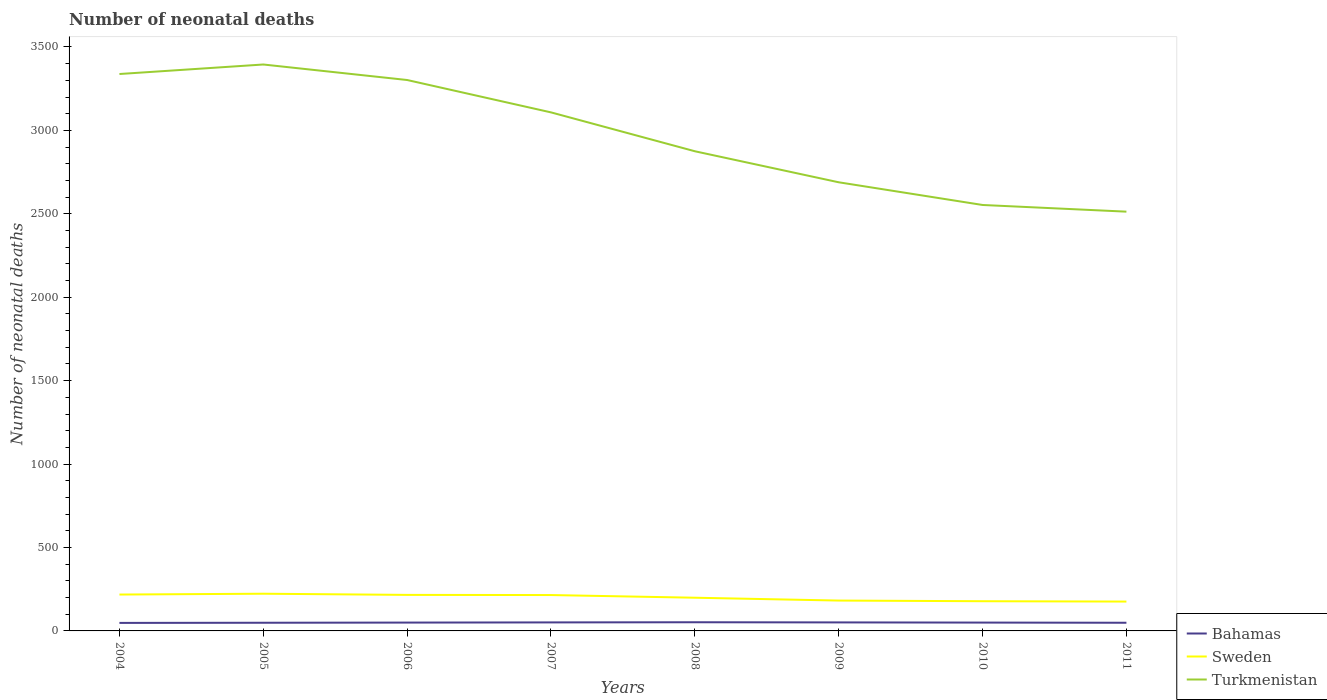Does the line corresponding to Bahamas intersect with the line corresponding to Turkmenistan?
Your answer should be very brief. No. Across all years, what is the maximum number of neonatal deaths in in Turkmenistan?
Offer a terse response. 2513. What is the total number of neonatal deaths in in Turkmenistan in the graph?
Your answer should be very brief. 40. What is the difference between the highest and the second highest number of neonatal deaths in in Turkmenistan?
Offer a very short reply. 882. What is the difference between the highest and the lowest number of neonatal deaths in in Sweden?
Your answer should be compact. 4. How many lines are there?
Offer a very short reply. 3. What is the difference between two consecutive major ticks on the Y-axis?
Ensure brevity in your answer.  500. Are the values on the major ticks of Y-axis written in scientific E-notation?
Offer a very short reply. No. Does the graph contain any zero values?
Provide a short and direct response. No. Does the graph contain grids?
Your answer should be compact. No. Where does the legend appear in the graph?
Keep it short and to the point. Bottom right. How many legend labels are there?
Ensure brevity in your answer.  3. What is the title of the graph?
Ensure brevity in your answer.  Number of neonatal deaths. What is the label or title of the X-axis?
Offer a very short reply. Years. What is the label or title of the Y-axis?
Ensure brevity in your answer.  Number of neonatal deaths. What is the Number of neonatal deaths in Bahamas in 2004?
Keep it short and to the point. 48. What is the Number of neonatal deaths in Sweden in 2004?
Your answer should be very brief. 218. What is the Number of neonatal deaths of Turkmenistan in 2004?
Provide a short and direct response. 3338. What is the Number of neonatal deaths of Sweden in 2005?
Provide a succinct answer. 223. What is the Number of neonatal deaths of Turkmenistan in 2005?
Your answer should be very brief. 3395. What is the Number of neonatal deaths in Bahamas in 2006?
Your answer should be compact. 50. What is the Number of neonatal deaths of Sweden in 2006?
Make the answer very short. 216. What is the Number of neonatal deaths of Turkmenistan in 2006?
Keep it short and to the point. 3302. What is the Number of neonatal deaths of Bahamas in 2007?
Your response must be concise. 51. What is the Number of neonatal deaths in Sweden in 2007?
Your answer should be compact. 215. What is the Number of neonatal deaths of Turkmenistan in 2007?
Give a very brief answer. 3108. What is the Number of neonatal deaths in Sweden in 2008?
Make the answer very short. 199. What is the Number of neonatal deaths of Turkmenistan in 2008?
Offer a very short reply. 2875. What is the Number of neonatal deaths of Sweden in 2009?
Offer a very short reply. 182. What is the Number of neonatal deaths in Turkmenistan in 2009?
Provide a succinct answer. 2689. What is the Number of neonatal deaths in Bahamas in 2010?
Ensure brevity in your answer.  50. What is the Number of neonatal deaths of Sweden in 2010?
Your answer should be very brief. 178. What is the Number of neonatal deaths of Turkmenistan in 2010?
Offer a very short reply. 2553. What is the Number of neonatal deaths in Sweden in 2011?
Give a very brief answer. 176. What is the Number of neonatal deaths of Turkmenistan in 2011?
Your response must be concise. 2513. Across all years, what is the maximum Number of neonatal deaths of Sweden?
Your answer should be compact. 223. Across all years, what is the maximum Number of neonatal deaths in Turkmenistan?
Offer a terse response. 3395. Across all years, what is the minimum Number of neonatal deaths in Bahamas?
Provide a succinct answer. 48. Across all years, what is the minimum Number of neonatal deaths in Sweden?
Keep it short and to the point. 176. Across all years, what is the minimum Number of neonatal deaths in Turkmenistan?
Your answer should be compact. 2513. What is the total Number of neonatal deaths in Bahamas in the graph?
Your answer should be very brief. 400. What is the total Number of neonatal deaths in Sweden in the graph?
Your answer should be very brief. 1607. What is the total Number of neonatal deaths in Turkmenistan in the graph?
Make the answer very short. 2.38e+04. What is the difference between the Number of neonatal deaths of Turkmenistan in 2004 and that in 2005?
Offer a very short reply. -57. What is the difference between the Number of neonatal deaths in Bahamas in 2004 and that in 2006?
Make the answer very short. -2. What is the difference between the Number of neonatal deaths of Sweden in 2004 and that in 2006?
Keep it short and to the point. 2. What is the difference between the Number of neonatal deaths of Turkmenistan in 2004 and that in 2006?
Make the answer very short. 36. What is the difference between the Number of neonatal deaths in Bahamas in 2004 and that in 2007?
Keep it short and to the point. -3. What is the difference between the Number of neonatal deaths in Turkmenistan in 2004 and that in 2007?
Provide a short and direct response. 230. What is the difference between the Number of neonatal deaths in Bahamas in 2004 and that in 2008?
Ensure brevity in your answer.  -4. What is the difference between the Number of neonatal deaths in Sweden in 2004 and that in 2008?
Ensure brevity in your answer.  19. What is the difference between the Number of neonatal deaths of Turkmenistan in 2004 and that in 2008?
Your answer should be very brief. 463. What is the difference between the Number of neonatal deaths in Bahamas in 2004 and that in 2009?
Provide a succinct answer. -3. What is the difference between the Number of neonatal deaths of Turkmenistan in 2004 and that in 2009?
Ensure brevity in your answer.  649. What is the difference between the Number of neonatal deaths in Turkmenistan in 2004 and that in 2010?
Make the answer very short. 785. What is the difference between the Number of neonatal deaths of Bahamas in 2004 and that in 2011?
Ensure brevity in your answer.  -1. What is the difference between the Number of neonatal deaths of Sweden in 2004 and that in 2011?
Offer a very short reply. 42. What is the difference between the Number of neonatal deaths in Turkmenistan in 2004 and that in 2011?
Ensure brevity in your answer.  825. What is the difference between the Number of neonatal deaths in Sweden in 2005 and that in 2006?
Your answer should be very brief. 7. What is the difference between the Number of neonatal deaths of Turkmenistan in 2005 and that in 2006?
Your response must be concise. 93. What is the difference between the Number of neonatal deaths of Sweden in 2005 and that in 2007?
Your response must be concise. 8. What is the difference between the Number of neonatal deaths of Turkmenistan in 2005 and that in 2007?
Your answer should be very brief. 287. What is the difference between the Number of neonatal deaths of Bahamas in 2005 and that in 2008?
Your response must be concise. -3. What is the difference between the Number of neonatal deaths in Sweden in 2005 and that in 2008?
Your answer should be compact. 24. What is the difference between the Number of neonatal deaths in Turkmenistan in 2005 and that in 2008?
Your answer should be compact. 520. What is the difference between the Number of neonatal deaths of Bahamas in 2005 and that in 2009?
Offer a terse response. -2. What is the difference between the Number of neonatal deaths in Turkmenistan in 2005 and that in 2009?
Keep it short and to the point. 706. What is the difference between the Number of neonatal deaths of Turkmenistan in 2005 and that in 2010?
Ensure brevity in your answer.  842. What is the difference between the Number of neonatal deaths of Turkmenistan in 2005 and that in 2011?
Give a very brief answer. 882. What is the difference between the Number of neonatal deaths in Bahamas in 2006 and that in 2007?
Provide a short and direct response. -1. What is the difference between the Number of neonatal deaths in Sweden in 2006 and that in 2007?
Offer a terse response. 1. What is the difference between the Number of neonatal deaths of Turkmenistan in 2006 and that in 2007?
Keep it short and to the point. 194. What is the difference between the Number of neonatal deaths of Sweden in 2006 and that in 2008?
Provide a succinct answer. 17. What is the difference between the Number of neonatal deaths of Turkmenistan in 2006 and that in 2008?
Your answer should be very brief. 427. What is the difference between the Number of neonatal deaths in Bahamas in 2006 and that in 2009?
Offer a terse response. -1. What is the difference between the Number of neonatal deaths of Turkmenistan in 2006 and that in 2009?
Your response must be concise. 613. What is the difference between the Number of neonatal deaths in Turkmenistan in 2006 and that in 2010?
Offer a terse response. 749. What is the difference between the Number of neonatal deaths of Sweden in 2006 and that in 2011?
Your answer should be very brief. 40. What is the difference between the Number of neonatal deaths of Turkmenistan in 2006 and that in 2011?
Ensure brevity in your answer.  789. What is the difference between the Number of neonatal deaths of Bahamas in 2007 and that in 2008?
Make the answer very short. -1. What is the difference between the Number of neonatal deaths of Sweden in 2007 and that in 2008?
Offer a terse response. 16. What is the difference between the Number of neonatal deaths in Turkmenistan in 2007 and that in 2008?
Offer a terse response. 233. What is the difference between the Number of neonatal deaths of Bahamas in 2007 and that in 2009?
Provide a short and direct response. 0. What is the difference between the Number of neonatal deaths in Sweden in 2007 and that in 2009?
Ensure brevity in your answer.  33. What is the difference between the Number of neonatal deaths in Turkmenistan in 2007 and that in 2009?
Offer a very short reply. 419. What is the difference between the Number of neonatal deaths of Turkmenistan in 2007 and that in 2010?
Your answer should be very brief. 555. What is the difference between the Number of neonatal deaths in Bahamas in 2007 and that in 2011?
Give a very brief answer. 2. What is the difference between the Number of neonatal deaths of Turkmenistan in 2007 and that in 2011?
Ensure brevity in your answer.  595. What is the difference between the Number of neonatal deaths of Sweden in 2008 and that in 2009?
Make the answer very short. 17. What is the difference between the Number of neonatal deaths in Turkmenistan in 2008 and that in 2009?
Make the answer very short. 186. What is the difference between the Number of neonatal deaths in Sweden in 2008 and that in 2010?
Your response must be concise. 21. What is the difference between the Number of neonatal deaths in Turkmenistan in 2008 and that in 2010?
Give a very brief answer. 322. What is the difference between the Number of neonatal deaths in Bahamas in 2008 and that in 2011?
Provide a succinct answer. 3. What is the difference between the Number of neonatal deaths in Sweden in 2008 and that in 2011?
Keep it short and to the point. 23. What is the difference between the Number of neonatal deaths in Turkmenistan in 2008 and that in 2011?
Give a very brief answer. 362. What is the difference between the Number of neonatal deaths of Bahamas in 2009 and that in 2010?
Provide a succinct answer. 1. What is the difference between the Number of neonatal deaths of Sweden in 2009 and that in 2010?
Your response must be concise. 4. What is the difference between the Number of neonatal deaths in Turkmenistan in 2009 and that in 2010?
Ensure brevity in your answer.  136. What is the difference between the Number of neonatal deaths of Sweden in 2009 and that in 2011?
Keep it short and to the point. 6. What is the difference between the Number of neonatal deaths in Turkmenistan in 2009 and that in 2011?
Your response must be concise. 176. What is the difference between the Number of neonatal deaths of Sweden in 2010 and that in 2011?
Your response must be concise. 2. What is the difference between the Number of neonatal deaths of Bahamas in 2004 and the Number of neonatal deaths of Sweden in 2005?
Give a very brief answer. -175. What is the difference between the Number of neonatal deaths in Bahamas in 2004 and the Number of neonatal deaths in Turkmenistan in 2005?
Offer a terse response. -3347. What is the difference between the Number of neonatal deaths of Sweden in 2004 and the Number of neonatal deaths of Turkmenistan in 2005?
Your answer should be very brief. -3177. What is the difference between the Number of neonatal deaths in Bahamas in 2004 and the Number of neonatal deaths in Sweden in 2006?
Provide a succinct answer. -168. What is the difference between the Number of neonatal deaths of Bahamas in 2004 and the Number of neonatal deaths of Turkmenistan in 2006?
Provide a short and direct response. -3254. What is the difference between the Number of neonatal deaths in Sweden in 2004 and the Number of neonatal deaths in Turkmenistan in 2006?
Keep it short and to the point. -3084. What is the difference between the Number of neonatal deaths of Bahamas in 2004 and the Number of neonatal deaths of Sweden in 2007?
Provide a short and direct response. -167. What is the difference between the Number of neonatal deaths of Bahamas in 2004 and the Number of neonatal deaths of Turkmenistan in 2007?
Provide a succinct answer. -3060. What is the difference between the Number of neonatal deaths in Sweden in 2004 and the Number of neonatal deaths in Turkmenistan in 2007?
Offer a very short reply. -2890. What is the difference between the Number of neonatal deaths in Bahamas in 2004 and the Number of neonatal deaths in Sweden in 2008?
Keep it short and to the point. -151. What is the difference between the Number of neonatal deaths in Bahamas in 2004 and the Number of neonatal deaths in Turkmenistan in 2008?
Your answer should be very brief. -2827. What is the difference between the Number of neonatal deaths in Sweden in 2004 and the Number of neonatal deaths in Turkmenistan in 2008?
Offer a very short reply. -2657. What is the difference between the Number of neonatal deaths in Bahamas in 2004 and the Number of neonatal deaths in Sweden in 2009?
Keep it short and to the point. -134. What is the difference between the Number of neonatal deaths of Bahamas in 2004 and the Number of neonatal deaths of Turkmenistan in 2009?
Provide a short and direct response. -2641. What is the difference between the Number of neonatal deaths in Sweden in 2004 and the Number of neonatal deaths in Turkmenistan in 2009?
Make the answer very short. -2471. What is the difference between the Number of neonatal deaths in Bahamas in 2004 and the Number of neonatal deaths in Sweden in 2010?
Keep it short and to the point. -130. What is the difference between the Number of neonatal deaths of Bahamas in 2004 and the Number of neonatal deaths of Turkmenistan in 2010?
Make the answer very short. -2505. What is the difference between the Number of neonatal deaths of Sweden in 2004 and the Number of neonatal deaths of Turkmenistan in 2010?
Make the answer very short. -2335. What is the difference between the Number of neonatal deaths in Bahamas in 2004 and the Number of neonatal deaths in Sweden in 2011?
Provide a succinct answer. -128. What is the difference between the Number of neonatal deaths of Bahamas in 2004 and the Number of neonatal deaths of Turkmenistan in 2011?
Provide a short and direct response. -2465. What is the difference between the Number of neonatal deaths of Sweden in 2004 and the Number of neonatal deaths of Turkmenistan in 2011?
Your response must be concise. -2295. What is the difference between the Number of neonatal deaths in Bahamas in 2005 and the Number of neonatal deaths in Sweden in 2006?
Provide a succinct answer. -167. What is the difference between the Number of neonatal deaths in Bahamas in 2005 and the Number of neonatal deaths in Turkmenistan in 2006?
Your response must be concise. -3253. What is the difference between the Number of neonatal deaths of Sweden in 2005 and the Number of neonatal deaths of Turkmenistan in 2006?
Provide a short and direct response. -3079. What is the difference between the Number of neonatal deaths in Bahamas in 2005 and the Number of neonatal deaths in Sweden in 2007?
Offer a terse response. -166. What is the difference between the Number of neonatal deaths in Bahamas in 2005 and the Number of neonatal deaths in Turkmenistan in 2007?
Offer a terse response. -3059. What is the difference between the Number of neonatal deaths in Sweden in 2005 and the Number of neonatal deaths in Turkmenistan in 2007?
Give a very brief answer. -2885. What is the difference between the Number of neonatal deaths in Bahamas in 2005 and the Number of neonatal deaths in Sweden in 2008?
Keep it short and to the point. -150. What is the difference between the Number of neonatal deaths of Bahamas in 2005 and the Number of neonatal deaths of Turkmenistan in 2008?
Give a very brief answer. -2826. What is the difference between the Number of neonatal deaths of Sweden in 2005 and the Number of neonatal deaths of Turkmenistan in 2008?
Your answer should be very brief. -2652. What is the difference between the Number of neonatal deaths of Bahamas in 2005 and the Number of neonatal deaths of Sweden in 2009?
Offer a very short reply. -133. What is the difference between the Number of neonatal deaths of Bahamas in 2005 and the Number of neonatal deaths of Turkmenistan in 2009?
Your response must be concise. -2640. What is the difference between the Number of neonatal deaths in Sweden in 2005 and the Number of neonatal deaths in Turkmenistan in 2009?
Give a very brief answer. -2466. What is the difference between the Number of neonatal deaths of Bahamas in 2005 and the Number of neonatal deaths of Sweden in 2010?
Your answer should be compact. -129. What is the difference between the Number of neonatal deaths of Bahamas in 2005 and the Number of neonatal deaths of Turkmenistan in 2010?
Make the answer very short. -2504. What is the difference between the Number of neonatal deaths of Sweden in 2005 and the Number of neonatal deaths of Turkmenistan in 2010?
Give a very brief answer. -2330. What is the difference between the Number of neonatal deaths of Bahamas in 2005 and the Number of neonatal deaths of Sweden in 2011?
Your response must be concise. -127. What is the difference between the Number of neonatal deaths of Bahamas in 2005 and the Number of neonatal deaths of Turkmenistan in 2011?
Provide a succinct answer. -2464. What is the difference between the Number of neonatal deaths in Sweden in 2005 and the Number of neonatal deaths in Turkmenistan in 2011?
Offer a very short reply. -2290. What is the difference between the Number of neonatal deaths in Bahamas in 2006 and the Number of neonatal deaths in Sweden in 2007?
Your response must be concise. -165. What is the difference between the Number of neonatal deaths in Bahamas in 2006 and the Number of neonatal deaths in Turkmenistan in 2007?
Your answer should be very brief. -3058. What is the difference between the Number of neonatal deaths in Sweden in 2006 and the Number of neonatal deaths in Turkmenistan in 2007?
Your response must be concise. -2892. What is the difference between the Number of neonatal deaths in Bahamas in 2006 and the Number of neonatal deaths in Sweden in 2008?
Make the answer very short. -149. What is the difference between the Number of neonatal deaths of Bahamas in 2006 and the Number of neonatal deaths of Turkmenistan in 2008?
Your answer should be very brief. -2825. What is the difference between the Number of neonatal deaths of Sweden in 2006 and the Number of neonatal deaths of Turkmenistan in 2008?
Your answer should be compact. -2659. What is the difference between the Number of neonatal deaths of Bahamas in 2006 and the Number of neonatal deaths of Sweden in 2009?
Give a very brief answer. -132. What is the difference between the Number of neonatal deaths in Bahamas in 2006 and the Number of neonatal deaths in Turkmenistan in 2009?
Your response must be concise. -2639. What is the difference between the Number of neonatal deaths in Sweden in 2006 and the Number of neonatal deaths in Turkmenistan in 2009?
Your response must be concise. -2473. What is the difference between the Number of neonatal deaths of Bahamas in 2006 and the Number of neonatal deaths of Sweden in 2010?
Keep it short and to the point. -128. What is the difference between the Number of neonatal deaths in Bahamas in 2006 and the Number of neonatal deaths in Turkmenistan in 2010?
Your answer should be compact. -2503. What is the difference between the Number of neonatal deaths in Sweden in 2006 and the Number of neonatal deaths in Turkmenistan in 2010?
Offer a very short reply. -2337. What is the difference between the Number of neonatal deaths in Bahamas in 2006 and the Number of neonatal deaths in Sweden in 2011?
Your response must be concise. -126. What is the difference between the Number of neonatal deaths of Bahamas in 2006 and the Number of neonatal deaths of Turkmenistan in 2011?
Your answer should be compact. -2463. What is the difference between the Number of neonatal deaths in Sweden in 2006 and the Number of neonatal deaths in Turkmenistan in 2011?
Provide a succinct answer. -2297. What is the difference between the Number of neonatal deaths of Bahamas in 2007 and the Number of neonatal deaths of Sweden in 2008?
Your answer should be very brief. -148. What is the difference between the Number of neonatal deaths in Bahamas in 2007 and the Number of neonatal deaths in Turkmenistan in 2008?
Provide a short and direct response. -2824. What is the difference between the Number of neonatal deaths of Sweden in 2007 and the Number of neonatal deaths of Turkmenistan in 2008?
Offer a very short reply. -2660. What is the difference between the Number of neonatal deaths in Bahamas in 2007 and the Number of neonatal deaths in Sweden in 2009?
Offer a terse response. -131. What is the difference between the Number of neonatal deaths in Bahamas in 2007 and the Number of neonatal deaths in Turkmenistan in 2009?
Your answer should be compact. -2638. What is the difference between the Number of neonatal deaths of Sweden in 2007 and the Number of neonatal deaths of Turkmenistan in 2009?
Your answer should be compact. -2474. What is the difference between the Number of neonatal deaths of Bahamas in 2007 and the Number of neonatal deaths of Sweden in 2010?
Provide a short and direct response. -127. What is the difference between the Number of neonatal deaths in Bahamas in 2007 and the Number of neonatal deaths in Turkmenistan in 2010?
Ensure brevity in your answer.  -2502. What is the difference between the Number of neonatal deaths in Sweden in 2007 and the Number of neonatal deaths in Turkmenistan in 2010?
Give a very brief answer. -2338. What is the difference between the Number of neonatal deaths in Bahamas in 2007 and the Number of neonatal deaths in Sweden in 2011?
Provide a succinct answer. -125. What is the difference between the Number of neonatal deaths in Bahamas in 2007 and the Number of neonatal deaths in Turkmenistan in 2011?
Your answer should be compact. -2462. What is the difference between the Number of neonatal deaths of Sweden in 2007 and the Number of neonatal deaths of Turkmenistan in 2011?
Your answer should be very brief. -2298. What is the difference between the Number of neonatal deaths of Bahamas in 2008 and the Number of neonatal deaths of Sweden in 2009?
Your answer should be very brief. -130. What is the difference between the Number of neonatal deaths in Bahamas in 2008 and the Number of neonatal deaths in Turkmenistan in 2009?
Make the answer very short. -2637. What is the difference between the Number of neonatal deaths of Sweden in 2008 and the Number of neonatal deaths of Turkmenistan in 2009?
Give a very brief answer. -2490. What is the difference between the Number of neonatal deaths of Bahamas in 2008 and the Number of neonatal deaths of Sweden in 2010?
Offer a very short reply. -126. What is the difference between the Number of neonatal deaths in Bahamas in 2008 and the Number of neonatal deaths in Turkmenistan in 2010?
Keep it short and to the point. -2501. What is the difference between the Number of neonatal deaths in Sweden in 2008 and the Number of neonatal deaths in Turkmenistan in 2010?
Make the answer very short. -2354. What is the difference between the Number of neonatal deaths of Bahamas in 2008 and the Number of neonatal deaths of Sweden in 2011?
Keep it short and to the point. -124. What is the difference between the Number of neonatal deaths of Bahamas in 2008 and the Number of neonatal deaths of Turkmenistan in 2011?
Offer a very short reply. -2461. What is the difference between the Number of neonatal deaths of Sweden in 2008 and the Number of neonatal deaths of Turkmenistan in 2011?
Your answer should be very brief. -2314. What is the difference between the Number of neonatal deaths of Bahamas in 2009 and the Number of neonatal deaths of Sweden in 2010?
Your answer should be very brief. -127. What is the difference between the Number of neonatal deaths of Bahamas in 2009 and the Number of neonatal deaths of Turkmenistan in 2010?
Keep it short and to the point. -2502. What is the difference between the Number of neonatal deaths in Sweden in 2009 and the Number of neonatal deaths in Turkmenistan in 2010?
Offer a terse response. -2371. What is the difference between the Number of neonatal deaths in Bahamas in 2009 and the Number of neonatal deaths in Sweden in 2011?
Your response must be concise. -125. What is the difference between the Number of neonatal deaths of Bahamas in 2009 and the Number of neonatal deaths of Turkmenistan in 2011?
Give a very brief answer. -2462. What is the difference between the Number of neonatal deaths of Sweden in 2009 and the Number of neonatal deaths of Turkmenistan in 2011?
Your answer should be compact. -2331. What is the difference between the Number of neonatal deaths of Bahamas in 2010 and the Number of neonatal deaths of Sweden in 2011?
Your response must be concise. -126. What is the difference between the Number of neonatal deaths of Bahamas in 2010 and the Number of neonatal deaths of Turkmenistan in 2011?
Provide a succinct answer. -2463. What is the difference between the Number of neonatal deaths of Sweden in 2010 and the Number of neonatal deaths of Turkmenistan in 2011?
Give a very brief answer. -2335. What is the average Number of neonatal deaths in Bahamas per year?
Keep it short and to the point. 50. What is the average Number of neonatal deaths in Sweden per year?
Your answer should be very brief. 200.88. What is the average Number of neonatal deaths in Turkmenistan per year?
Offer a very short reply. 2971.62. In the year 2004, what is the difference between the Number of neonatal deaths in Bahamas and Number of neonatal deaths in Sweden?
Keep it short and to the point. -170. In the year 2004, what is the difference between the Number of neonatal deaths in Bahamas and Number of neonatal deaths in Turkmenistan?
Make the answer very short. -3290. In the year 2004, what is the difference between the Number of neonatal deaths of Sweden and Number of neonatal deaths of Turkmenistan?
Give a very brief answer. -3120. In the year 2005, what is the difference between the Number of neonatal deaths in Bahamas and Number of neonatal deaths in Sweden?
Your answer should be very brief. -174. In the year 2005, what is the difference between the Number of neonatal deaths in Bahamas and Number of neonatal deaths in Turkmenistan?
Keep it short and to the point. -3346. In the year 2005, what is the difference between the Number of neonatal deaths in Sweden and Number of neonatal deaths in Turkmenistan?
Ensure brevity in your answer.  -3172. In the year 2006, what is the difference between the Number of neonatal deaths of Bahamas and Number of neonatal deaths of Sweden?
Provide a short and direct response. -166. In the year 2006, what is the difference between the Number of neonatal deaths in Bahamas and Number of neonatal deaths in Turkmenistan?
Provide a succinct answer. -3252. In the year 2006, what is the difference between the Number of neonatal deaths in Sweden and Number of neonatal deaths in Turkmenistan?
Offer a terse response. -3086. In the year 2007, what is the difference between the Number of neonatal deaths in Bahamas and Number of neonatal deaths in Sweden?
Provide a short and direct response. -164. In the year 2007, what is the difference between the Number of neonatal deaths of Bahamas and Number of neonatal deaths of Turkmenistan?
Your answer should be very brief. -3057. In the year 2007, what is the difference between the Number of neonatal deaths in Sweden and Number of neonatal deaths in Turkmenistan?
Your answer should be very brief. -2893. In the year 2008, what is the difference between the Number of neonatal deaths in Bahamas and Number of neonatal deaths in Sweden?
Ensure brevity in your answer.  -147. In the year 2008, what is the difference between the Number of neonatal deaths in Bahamas and Number of neonatal deaths in Turkmenistan?
Your answer should be very brief. -2823. In the year 2008, what is the difference between the Number of neonatal deaths of Sweden and Number of neonatal deaths of Turkmenistan?
Your answer should be very brief. -2676. In the year 2009, what is the difference between the Number of neonatal deaths in Bahamas and Number of neonatal deaths in Sweden?
Offer a terse response. -131. In the year 2009, what is the difference between the Number of neonatal deaths of Bahamas and Number of neonatal deaths of Turkmenistan?
Give a very brief answer. -2638. In the year 2009, what is the difference between the Number of neonatal deaths of Sweden and Number of neonatal deaths of Turkmenistan?
Ensure brevity in your answer.  -2507. In the year 2010, what is the difference between the Number of neonatal deaths in Bahamas and Number of neonatal deaths in Sweden?
Provide a succinct answer. -128. In the year 2010, what is the difference between the Number of neonatal deaths in Bahamas and Number of neonatal deaths in Turkmenistan?
Offer a terse response. -2503. In the year 2010, what is the difference between the Number of neonatal deaths of Sweden and Number of neonatal deaths of Turkmenistan?
Your answer should be very brief. -2375. In the year 2011, what is the difference between the Number of neonatal deaths of Bahamas and Number of neonatal deaths of Sweden?
Your response must be concise. -127. In the year 2011, what is the difference between the Number of neonatal deaths in Bahamas and Number of neonatal deaths in Turkmenistan?
Your answer should be compact. -2464. In the year 2011, what is the difference between the Number of neonatal deaths in Sweden and Number of neonatal deaths in Turkmenistan?
Keep it short and to the point. -2337. What is the ratio of the Number of neonatal deaths in Bahamas in 2004 to that in 2005?
Keep it short and to the point. 0.98. What is the ratio of the Number of neonatal deaths in Sweden in 2004 to that in 2005?
Make the answer very short. 0.98. What is the ratio of the Number of neonatal deaths in Turkmenistan in 2004 to that in 2005?
Your answer should be compact. 0.98. What is the ratio of the Number of neonatal deaths of Bahamas in 2004 to that in 2006?
Give a very brief answer. 0.96. What is the ratio of the Number of neonatal deaths of Sweden in 2004 to that in 2006?
Your answer should be compact. 1.01. What is the ratio of the Number of neonatal deaths in Turkmenistan in 2004 to that in 2006?
Provide a succinct answer. 1.01. What is the ratio of the Number of neonatal deaths in Bahamas in 2004 to that in 2007?
Offer a very short reply. 0.94. What is the ratio of the Number of neonatal deaths in Sweden in 2004 to that in 2007?
Offer a terse response. 1.01. What is the ratio of the Number of neonatal deaths in Turkmenistan in 2004 to that in 2007?
Provide a succinct answer. 1.07. What is the ratio of the Number of neonatal deaths in Bahamas in 2004 to that in 2008?
Offer a terse response. 0.92. What is the ratio of the Number of neonatal deaths of Sweden in 2004 to that in 2008?
Give a very brief answer. 1.1. What is the ratio of the Number of neonatal deaths of Turkmenistan in 2004 to that in 2008?
Your answer should be compact. 1.16. What is the ratio of the Number of neonatal deaths in Sweden in 2004 to that in 2009?
Keep it short and to the point. 1.2. What is the ratio of the Number of neonatal deaths in Turkmenistan in 2004 to that in 2009?
Your answer should be compact. 1.24. What is the ratio of the Number of neonatal deaths of Bahamas in 2004 to that in 2010?
Your answer should be compact. 0.96. What is the ratio of the Number of neonatal deaths of Sweden in 2004 to that in 2010?
Keep it short and to the point. 1.22. What is the ratio of the Number of neonatal deaths of Turkmenistan in 2004 to that in 2010?
Your answer should be compact. 1.31. What is the ratio of the Number of neonatal deaths of Bahamas in 2004 to that in 2011?
Provide a short and direct response. 0.98. What is the ratio of the Number of neonatal deaths in Sweden in 2004 to that in 2011?
Give a very brief answer. 1.24. What is the ratio of the Number of neonatal deaths of Turkmenistan in 2004 to that in 2011?
Your answer should be compact. 1.33. What is the ratio of the Number of neonatal deaths in Bahamas in 2005 to that in 2006?
Ensure brevity in your answer.  0.98. What is the ratio of the Number of neonatal deaths of Sweden in 2005 to that in 2006?
Provide a short and direct response. 1.03. What is the ratio of the Number of neonatal deaths of Turkmenistan in 2005 to that in 2006?
Make the answer very short. 1.03. What is the ratio of the Number of neonatal deaths in Bahamas in 2005 to that in 2007?
Keep it short and to the point. 0.96. What is the ratio of the Number of neonatal deaths in Sweden in 2005 to that in 2007?
Provide a succinct answer. 1.04. What is the ratio of the Number of neonatal deaths of Turkmenistan in 2005 to that in 2007?
Provide a short and direct response. 1.09. What is the ratio of the Number of neonatal deaths in Bahamas in 2005 to that in 2008?
Keep it short and to the point. 0.94. What is the ratio of the Number of neonatal deaths in Sweden in 2005 to that in 2008?
Keep it short and to the point. 1.12. What is the ratio of the Number of neonatal deaths of Turkmenistan in 2005 to that in 2008?
Ensure brevity in your answer.  1.18. What is the ratio of the Number of neonatal deaths in Bahamas in 2005 to that in 2009?
Offer a very short reply. 0.96. What is the ratio of the Number of neonatal deaths in Sweden in 2005 to that in 2009?
Make the answer very short. 1.23. What is the ratio of the Number of neonatal deaths of Turkmenistan in 2005 to that in 2009?
Provide a succinct answer. 1.26. What is the ratio of the Number of neonatal deaths in Sweden in 2005 to that in 2010?
Provide a succinct answer. 1.25. What is the ratio of the Number of neonatal deaths of Turkmenistan in 2005 to that in 2010?
Make the answer very short. 1.33. What is the ratio of the Number of neonatal deaths in Bahamas in 2005 to that in 2011?
Keep it short and to the point. 1. What is the ratio of the Number of neonatal deaths of Sweden in 2005 to that in 2011?
Offer a terse response. 1.27. What is the ratio of the Number of neonatal deaths of Turkmenistan in 2005 to that in 2011?
Make the answer very short. 1.35. What is the ratio of the Number of neonatal deaths of Bahamas in 2006 to that in 2007?
Your answer should be compact. 0.98. What is the ratio of the Number of neonatal deaths of Turkmenistan in 2006 to that in 2007?
Offer a very short reply. 1.06. What is the ratio of the Number of neonatal deaths of Bahamas in 2006 to that in 2008?
Offer a very short reply. 0.96. What is the ratio of the Number of neonatal deaths of Sweden in 2006 to that in 2008?
Ensure brevity in your answer.  1.09. What is the ratio of the Number of neonatal deaths in Turkmenistan in 2006 to that in 2008?
Ensure brevity in your answer.  1.15. What is the ratio of the Number of neonatal deaths of Bahamas in 2006 to that in 2009?
Your response must be concise. 0.98. What is the ratio of the Number of neonatal deaths of Sweden in 2006 to that in 2009?
Offer a terse response. 1.19. What is the ratio of the Number of neonatal deaths in Turkmenistan in 2006 to that in 2009?
Keep it short and to the point. 1.23. What is the ratio of the Number of neonatal deaths of Bahamas in 2006 to that in 2010?
Your answer should be very brief. 1. What is the ratio of the Number of neonatal deaths of Sweden in 2006 to that in 2010?
Offer a very short reply. 1.21. What is the ratio of the Number of neonatal deaths of Turkmenistan in 2006 to that in 2010?
Your answer should be very brief. 1.29. What is the ratio of the Number of neonatal deaths of Bahamas in 2006 to that in 2011?
Your response must be concise. 1.02. What is the ratio of the Number of neonatal deaths in Sweden in 2006 to that in 2011?
Your answer should be compact. 1.23. What is the ratio of the Number of neonatal deaths in Turkmenistan in 2006 to that in 2011?
Keep it short and to the point. 1.31. What is the ratio of the Number of neonatal deaths of Bahamas in 2007 to that in 2008?
Provide a succinct answer. 0.98. What is the ratio of the Number of neonatal deaths in Sweden in 2007 to that in 2008?
Your answer should be very brief. 1.08. What is the ratio of the Number of neonatal deaths of Turkmenistan in 2007 to that in 2008?
Offer a very short reply. 1.08. What is the ratio of the Number of neonatal deaths of Bahamas in 2007 to that in 2009?
Provide a succinct answer. 1. What is the ratio of the Number of neonatal deaths in Sweden in 2007 to that in 2009?
Your answer should be compact. 1.18. What is the ratio of the Number of neonatal deaths in Turkmenistan in 2007 to that in 2009?
Keep it short and to the point. 1.16. What is the ratio of the Number of neonatal deaths in Bahamas in 2007 to that in 2010?
Ensure brevity in your answer.  1.02. What is the ratio of the Number of neonatal deaths in Sweden in 2007 to that in 2010?
Your answer should be compact. 1.21. What is the ratio of the Number of neonatal deaths in Turkmenistan in 2007 to that in 2010?
Offer a very short reply. 1.22. What is the ratio of the Number of neonatal deaths in Bahamas in 2007 to that in 2011?
Give a very brief answer. 1.04. What is the ratio of the Number of neonatal deaths in Sweden in 2007 to that in 2011?
Make the answer very short. 1.22. What is the ratio of the Number of neonatal deaths in Turkmenistan in 2007 to that in 2011?
Your answer should be very brief. 1.24. What is the ratio of the Number of neonatal deaths in Bahamas in 2008 to that in 2009?
Give a very brief answer. 1.02. What is the ratio of the Number of neonatal deaths in Sweden in 2008 to that in 2009?
Give a very brief answer. 1.09. What is the ratio of the Number of neonatal deaths of Turkmenistan in 2008 to that in 2009?
Ensure brevity in your answer.  1.07. What is the ratio of the Number of neonatal deaths of Bahamas in 2008 to that in 2010?
Ensure brevity in your answer.  1.04. What is the ratio of the Number of neonatal deaths of Sweden in 2008 to that in 2010?
Provide a succinct answer. 1.12. What is the ratio of the Number of neonatal deaths in Turkmenistan in 2008 to that in 2010?
Keep it short and to the point. 1.13. What is the ratio of the Number of neonatal deaths in Bahamas in 2008 to that in 2011?
Make the answer very short. 1.06. What is the ratio of the Number of neonatal deaths of Sweden in 2008 to that in 2011?
Offer a very short reply. 1.13. What is the ratio of the Number of neonatal deaths of Turkmenistan in 2008 to that in 2011?
Your response must be concise. 1.14. What is the ratio of the Number of neonatal deaths of Sweden in 2009 to that in 2010?
Give a very brief answer. 1.02. What is the ratio of the Number of neonatal deaths of Turkmenistan in 2009 to that in 2010?
Give a very brief answer. 1.05. What is the ratio of the Number of neonatal deaths of Bahamas in 2009 to that in 2011?
Make the answer very short. 1.04. What is the ratio of the Number of neonatal deaths in Sweden in 2009 to that in 2011?
Provide a short and direct response. 1.03. What is the ratio of the Number of neonatal deaths of Turkmenistan in 2009 to that in 2011?
Your response must be concise. 1.07. What is the ratio of the Number of neonatal deaths of Bahamas in 2010 to that in 2011?
Provide a short and direct response. 1.02. What is the ratio of the Number of neonatal deaths of Sweden in 2010 to that in 2011?
Your answer should be compact. 1.01. What is the ratio of the Number of neonatal deaths of Turkmenistan in 2010 to that in 2011?
Offer a terse response. 1.02. What is the difference between the highest and the second highest Number of neonatal deaths of Sweden?
Make the answer very short. 5. What is the difference between the highest and the lowest Number of neonatal deaths of Bahamas?
Your answer should be compact. 4. What is the difference between the highest and the lowest Number of neonatal deaths of Turkmenistan?
Give a very brief answer. 882. 